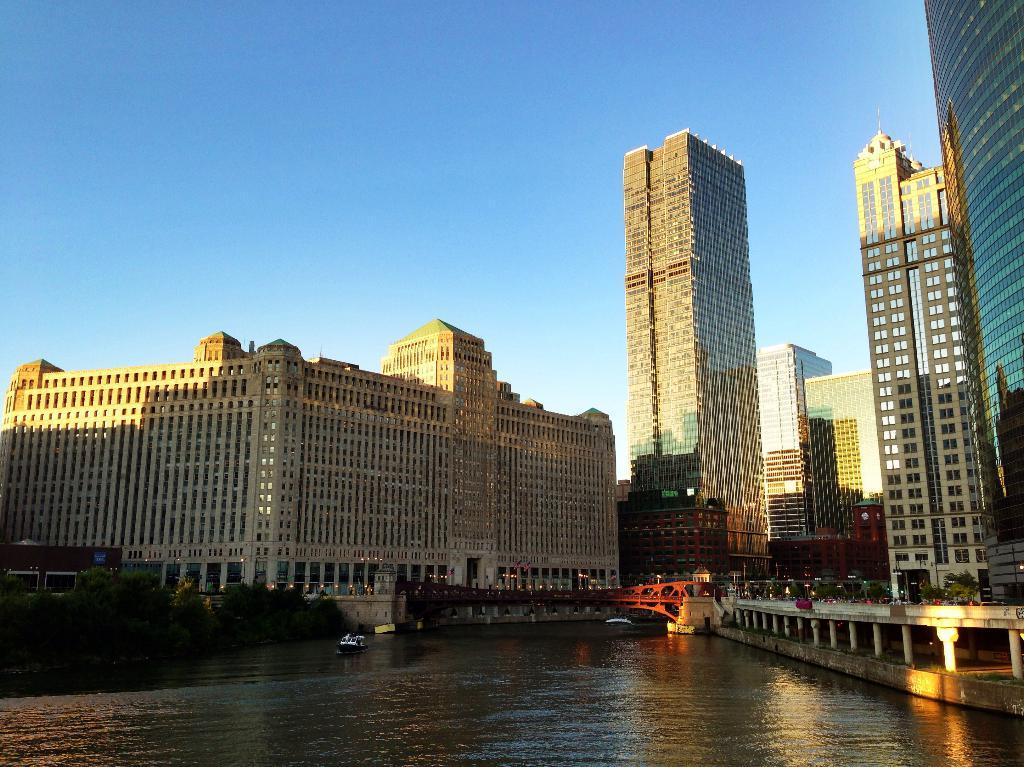What is at the bottom of the image? There is water at the bottom of the image. What can be seen in the middle of the image? There are buildings in the middle of the image. What is visible at the top of the image? The sky is visible at the top of the image. Where is the toy toad located in the image? There is no toy toad present in the image. What causes the water to stop flowing in the image? The water in the image is stationary, and there is no indication of it flowing or being stopped. 